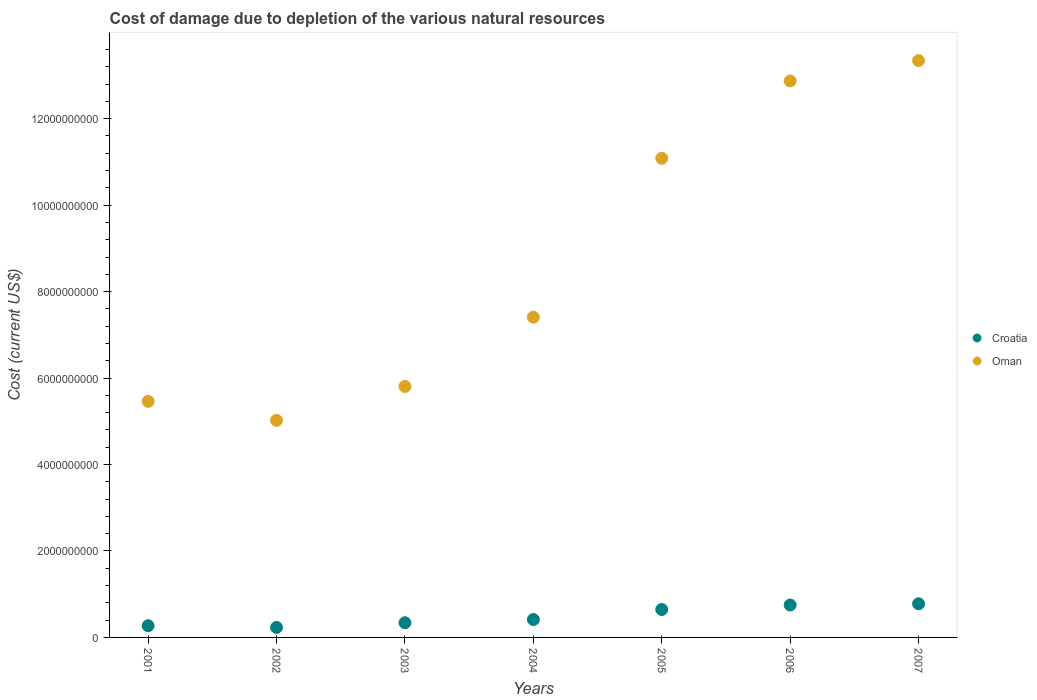Is the number of dotlines equal to the number of legend labels?
Make the answer very short. Yes. What is the cost of damage caused due to the depletion of various natural resources in Croatia in 2002?
Ensure brevity in your answer.  2.31e+08. Across all years, what is the maximum cost of damage caused due to the depletion of various natural resources in Oman?
Provide a short and direct response. 1.33e+1. Across all years, what is the minimum cost of damage caused due to the depletion of various natural resources in Croatia?
Ensure brevity in your answer.  2.31e+08. In which year was the cost of damage caused due to the depletion of various natural resources in Croatia minimum?
Make the answer very short. 2002. What is the total cost of damage caused due to the depletion of various natural resources in Oman in the graph?
Offer a very short reply. 6.10e+1. What is the difference between the cost of damage caused due to the depletion of various natural resources in Oman in 2001 and that in 2002?
Your answer should be very brief. 4.40e+08. What is the difference between the cost of damage caused due to the depletion of various natural resources in Croatia in 2006 and the cost of damage caused due to the depletion of various natural resources in Oman in 2004?
Provide a short and direct response. -6.66e+09. What is the average cost of damage caused due to the depletion of various natural resources in Oman per year?
Give a very brief answer. 8.71e+09. In the year 2005, what is the difference between the cost of damage caused due to the depletion of various natural resources in Oman and cost of damage caused due to the depletion of various natural resources in Croatia?
Keep it short and to the point. 1.04e+1. What is the ratio of the cost of damage caused due to the depletion of various natural resources in Oman in 2001 to that in 2003?
Offer a terse response. 0.94. Is the cost of damage caused due to the depletion of various natural resources in Croatia in 2005 less than that in 2007?
Your response must be concise. Yes. Is the difference between the cost of damage caused due to the depletion of various natural resources in Oman in 2001 and 2002 greater than the difference between the cost of damage caused due to the depletion of various natural resources in Croatia in 2001 and 2002?
Your answer should be compact. Yes. What is the difference between the highest and the second highest cost of damage caused due to the depletion of various natural resources in Oman?
Ensure brevity in your answer.  4.70e+08. What is the difference between the highest and the lowest cost of damage caused due to the depletion of various natural resources in Oman?
Offer a very short reply. 8.32e+09. Does the cost of damage caused due to the depletion of various natural resources in Croatia monotonically increase over the years?
Your response must be concise. No. Is the cost of damage caused due to the depletion of various natural resources in Croatia strictly greater than the cost of damage caused due to the depletion of various natural resources in Oman over the years?
Offer a terse response. No. Does the graph contain any zero values?
Offer a very short reply. No. Where does the legend appear in the graph?
Provide a succinct answer. Center right. What is the title of the graph?
Offer a terse response. Cost of damage due to depletion of the various natural resources. What is the label or title of the X-axis?
Your response must be concise. Years. What is the label or title of the Y-axis?
Keep it short and to the point. Cost (current US$). What is the Cost (current US$) in Croatia in 2001?
Ensure brevity in your answer.  2.71e+08. What is the Cost (current US$) in Oman in 2001?
Your response must be concise. 5.46e+09. What is the Cost (current US$) of Croatia in 2002?
Make the answer very short. 2.31e+08. What is the Cost (current US$) of Oman in 2002?
Your answer should be compact. 5.02e+09. What is the Cost (current US$) of Croatia in 2003?
Offer a terse response. 3.40e+08. What is the Cost (current US$) of Oman in 2003?
Keep it short and to the point. 5.81e+09. What is the Cost (current US$) in Croatia in 2004?
Your answer should be very brief. 4.14e+08. What is the Cost (current US$) in Oman in 2004?
Give a very brief answer. 7.41e+09. What is the Cost (current US$) of Croatia in 2005?
Your answer should be very brief. 6.46e+08. What is the Cost (current US$) in Oman in 2005?
Keep it short and to the point. 1.11e+1. What is the Cost (current US$) of Croatia in 2006?
Offer a terse response. 7.50e+08. What is the Cost (current US$) of Oman in 2006?
Offer a terse response. 1.29e+1. What is the Cost (current US$) of Croatia in 2007?
Your answer should be very brief. 7.78e+08. What is the Cost (current US$) of Oman in 2007?
Give a very brief answer. 1.33e+1. Across all years, what is the maximum Cost (current US$) of Croatia?
Your response must be concise. 7.78e+08. Across all years, what is the maximum Cost (current US$) of Oman?
Offer a very short reply. 1.33e+1. Across all years, what is the minimum Cost (current US$) of Croatia?
Keep it short and to the point. 2.31e+08. Across all years, what is the minimum Cost (current US$) of Oman?
Make the answer very short. 5.02e+09. What is the total Cost (current US$) of Croatia in the graph?
Provide a succinct answer. 3.43e+09. What is the total Cost (current US$) in Oman in the graph?
Ensure brevity in your answer.  6.10e+1. What is the difference between the Cost (current US$) in Croatia in 2001 and that in 2002?
Provide a short and direct response. 3.95e+07. What is the difference between the Cost (current US$) in Oman in 2001 and that in 2002?
Provide a short and direct response. 4.40e+08. What is the difference between the Cost (current US$) in Croatia in 2001 and that in 2003?
Keep it short and to the point. -6.90e+07. What is the difference between the Cost (current US$) in Oman in 2001 and that in 2003?
Provide a succinct answer. -3.44e+08. What is the difference between the Cost (current US$) in Croatia in 2001 and that in 2004?
Your response must be concise. -1.44e+08. What is the difference between the Cost (current US$) in Oman in 2001 and that in 2004?
Make the answer very short. -1.95e+09. What is the difference between the Cost (current US$) in Croatia in 2001 and that in 2005?
Make the answer very short. -3.75e+08. What is the difference between the Cost (current US$) in Oman in 2001 and that in 2005?
Your answer should be compact. -5.62e+09. What is the difference between the Cost (current US$) in Croatia in 2001 and that in 2006?
Make the answer very short. -4.79e+08. What is the difference between the Cost (current US$) of Oman in 2001 and that in 2006?
Provide a succinct answer. -7.41e+09. What is the difference between the Cost (current US$) of Croatia in 2001 and that in 2007?
Make the answer very short. -5.07e+08. What is the difference between the Cost (current US$) of Oman in 2001 and that in 2007?
Make the answer very short. -7.88e+09. What is the difference between the Cost (current US$) in Croatia in 2002 and that in 2003?
Your answer should be compact. -1.08e+08. What is the difference between the Cost (current US$) in Oman in 2002 and that in 2003?
Keep it short and to the point. -7.84e+08. What is the difference between the Cost (current US$) in Croatia in 2002 and that in 2004?
Your answer should be compact. -1.83e+08. What is the difference between the Cost (current US$) of Oman in 2002 and that in 2004?
Your answer should be very brief. -2.39e+09. What is the difference between the Cost (current US$) of Croatia in 2002 and that in 2005?
Offer a terse response. -4.14e+08. What is the difference between the Cost (current US$) of Oman in 2002 and that in 2005?
Provide a succinct answer. -6.06e+09. What is the difference between the Cost (current US$) in Croatia in 2002 and that in 2006?
Your answer should be very brief. -5.18e+08. What is the difference between the Cost (current US$) in Oman in 2002 and that in 2006?
Your answer should be very brief. -7.85e+09. What is the difference between the Cost (current US$) in Croatia in 2002 and that in 2007?
Provide a succinct answer. -5.47e+08. What is the difference between the Cost (current US$) in Oman in 2002 and that in 2007?
Offer a very short reply. -8.32e+09. What is the difference between the Cost (current US$) of Croatia in 2003 and that in 2004?
Make the answer very short. -7.47e+07. What is the difference between the Cost (current US$) of Oman in 2003 and that in 2004?
Give a very brief answer. -1.60e+09. What is the difference between the Cost (current US$) in Croatia in 2003 and that in 2005?
Provide a succinct answer. -3.06e+08. What is the difference between the Cost (current US$) of Oman in 2003 and that in 2005?
Your answer should be very brief. -5.28e+09. What is the difference between the Cost (current US$) in Croatia in 2003 and that in 2006?
Offer a very short reply. -4.10e+08. What is the difference between the Cost (current US$) of Oman in 2003 and that in 2006?
Ensure brevity in your answer.  -7.07e+09. What is the difference between the Cost (current US$) in Croatia in 2003 and that in 2007?
Offer a very short reply. -4.38e+08. What is the difference between the Cost (current US$) in Oman in 2003 and that in 2007?
Give a very brief answer. -7.54e+09. What is the difference between the Cost (current US$) of Croatia in 2004 and that in 2005?
Offer a very short reply. -2.31e+08. What is the difference between the Cost (current US$) of Oman in 2004 and that in 2005?
Ensure brevity in your answer.  -3.68e+09. What is the difference between the Cost (current US$) of Croatia in 2004 and that in 2006?
Keep it short and to the point. -3.35e+08. What is the difference between the Cost (current US$) in Oman in 2004 and that in 2006?
Give a very brief answer. -5.47e+09. What is the difference between the Cost (current US$) of Croatia in 2004 and that in 2007?
Give a very brief answer. -3.64e+08. What is the difference between the Cost (current US$) in Oman in 2004 and that in 2007?
Offer a terse response. -5.94e+09. What is the difference between the Cost (current US$) of Croatia in 2005 and that in 2006?
Offer a terse response. -1.04e+08. What is the difference between the Cost (current US$) of Oman in 2005 and that in 2006?
Keep it short and to the point. -1.79e+09. What is the difference between the Cost (current US$) of Croatia in 2005 and that in 2007?
Give a very brief answer. -1.32e+08. What is the difference between the Cost (current US$) in Oman in 2005 and that in 2007?
Provide a succinct answer. -2.26e+09. What is the difference between the Cost (current US$) of Croatia in 2006 and that in 2007?
Provide a succinct answer. -2.82e+07. What is the difference between the Cost (current US$) in Oman in 2006 and that in 2007?
Give a very brief answer. -4.70e+08. What is the difference between the Cost (current US$) in Croatia in 2001 and the Cost (current US$) in Oman in 2002?
Make the answer very short. -4.75e+09. What is the difference between the Cost (current US$) of Croatia in 2001 and the Cost (current US$) of Oman in 2003?
Provide a short and direct response. -5.53e+09. What is the difference between the Cost (current US$) of Croatia in 2001 and the Cost (current US$) of Oman in 2004?
Your answer should be compact. -7.14e+09. What is the difference between the Cost (current US$) in Croatia in 2001 and the Cost (current US$) in Oman in 2005?
Your response must be concise. -1.08e+1. What is the difference between the Cost (current US$) of Croatia in 2001 and the Cost (current US$) of Oman in 2006?
Provide a short and direct response. -1.26e+1. What is the difference between the Cost (current US$) in Croatia in 2001 and the Cost (current US$) in Oman in 2007?
Offer a terse response. -1.31e+1. What is the difference between the Cost (current US$) in Croatia in 2002 and the Cost (current US$) in Oman in 2003?
Offer a terse response. -5.57e+09. What is the difference between the Cost (current US$) of Croatia in 2002 and the Cost (current US$) of Oman in 2004?
Offer a very short reply. -7.18e+09. What is the difference between the Cost (current US$) in Croatia in 2002 and the Cost (current US$) in Oman in 2005?
Offer a very short reply. -1.09e+1. What is the difference between the Cost (current US$) of Croatia in 2002 and the Cost (current US$) of Oman in 2006?
Make the answer very short. -1.26e+1. What is the difference between the Cost (current US$) in Croatia in 2002 and the Cost (current US$) in Oman in 2007?
Ensure brevity in your answer.  -1.31e+1. What is the difference between the Cost (current US$) in Croatia in 2003 and the Cost (current US$) in Oman in 2004?
Offer a very short reply. -7.07e+09. What is the difference between the Cost (current US$) in Croatia in 2003 and the Cost (current US$) in Oman in 2005?
Provide a short and direct response. -1.07e+1. What is the difference between the Cost (current US$) in Croatia in 2003 and the Cost (current US$) in Oman in 2006?
Ensure brevity in your answer.  -1.25e+1. What is the difference between the Cost (current US$) in Croatia in 2003 and the Cost (current US$) in Oman in 2007?
Provide a succinct answer. -1.30e+1. What is the difference between the Cost (current US$) of Croatia in 2004 and the Cost (current US$) of Oman in 2005?
Offer a very short reply. -1.07e+1. What is the difference between the Cost (current US$) in Croatia in 2004 and the Cost (current US$) in Oman in 2006?
Give a very brief answer. -1.25e+1. What is the difference between the Cost (current US$) in Croatia in 2004 and the Cost (current US$) in Oman in 2007?
Your answer should be compact. -1.29e+1. What is the difference between the Cost (current US$) in Croatia in 2005 and the Cost (current US$) in Oman in 2006?
Offer a terse response. -1.22e+1. What is the difference between the Cost (current US$) of Croatia in 2005 and the Cost (current US$) of Oman in 2007?
Your answer should be compact. -1.27e+1. What is the difference between the Cost (current US$) of Croatia in 2006 and the Cost (current US$) of Oman in 2007?
Offer a very short reply. -1.26e+1. What is the average Cost (current US$) of Croatia per year?
Your response must be concise. 4.90e+08. What is the average Cost (current US$) in Oman per year?
Make the answer very short. 8.71e+09. In the year 2001, what is the difference between the Cost (current US$) of Croatia and Cost (current US$) of Oman?
Your answer should be compact. -5.19e+09. In the year 2002, what is the difference between the Cost (current US$) of Croatia and Cost (current US$) of Oman?
Offer a terse response. -4.79e+09. In the year 2003, what is the difference between the Cost (current US$) in Croatia and Cost (current US$) in Oman?
Ensure brevity in your answer.  -5.47e+09. In the year 2004, what is the difference between the Cost (current US$) in Croatia and Cost (current US$) in Oman?
Keep it short and to the point. -6.99e+09. In the year 2005, what is the difference between the Cost (current US$) of Croatia and Cost (current US$) of Oman?
Your response must be concise. -1.04e+1. In the year 2006, what is the difference between the Cost (current US$) of Croatia and Cost (current US$) of Oman?
Provide a short and direct response. -1.21e+1. In the year 2007, what is the difference between the Cost (current US$) in Croatia and Cost (current US$) in Oman?
Provide a short and direct response. -1.26e+1. What is the ratio of the Cost (current US$) of Croatia in 2001 to that in 2002?
Your answer should be very brief. 1.17. What is the ratio of the Cost (current US$) of Oman in 2001 to that in 2002?
Offer a terse response. 1.09. What is the ratio of the Cost (current US$) of Croatia in 2001 to that in 2003?
Keep it short and to the point. 0.8. What is the ratio of the Cost (current US$) in Oman in 2001 to that in 2003?
Provide a succinct answer. 0.94. What is the ratio of the Cost (current US$) of Croatia in 2001 to that in 2004?
Give a very brief answer. 0.65. What is the ratio of the Cost (current US$) in Oman in 2001 to that in 2004?
Ensure brevity in your answer.  0.74. What is the ratio of the Cost (current US$) of Croatia in 2001 to that in 2005?
Your response must be concise. 0.42. What is the ratio of the Cost (current US$) in Oman in 2001 to that in 2005?
Offer a terse response. 0.49. What is the ratio of the Cost (current US$) of Croatia in 2001 to that in 2006?
Your answer should be very brief. 0.36. What is the ratio of the Cost (current US$) of Oman in 2001 to that in 2006?
Provide a succinct answer. 0.42. What is the ratio of the Cost (current US$) of Croatia in 2001 to that in 2007?
Ensure brevity in your answer.  0.35. What is the ratio of the Cost (current US$) of Oman in 2001 to that in 2007?
Make the answer very short. 0.41. What is the ratio of the Cost (current US$) of Croatia in 2002 to that in 2003?
Make the answer very short. 0.68. What is the ratio of the Cost (current US$) of Oman in 2002 to that in 2003?
Your response must be concise. 0.86. What is the ratio of the Cost (current US$) of Croatia in 2002 to that in 2004?
Offer a terse response. 0.56. What is the ratio of the Cost (current US$) in Oman in 2002 to that in 2004?
Keep it short and to the point. 0.68. What is the ratio of the Cost (current US$) of Croatia in 2002 to that in 2005?
Make the answer very short. 0.36. What is the ratio of the Cost (current US$) of Oman in 2002 to that in 2005?
Keep it short and to the point. 0.45. What is the ratio of the Cost (current US$) of Croatia in 2002 to that in 2006?
Your answer should be very brief. 0.31. What is the ratio of the Cost (current US$) in Oman in 2002 to that in 2006?
Offer a terse response. 0.39. What is the ratio of the Cost (current US$) of Croatia in 2002 to that in 2007?
Your answer should be compact. 0.3. What is the ratio of the Cost (current US$) of Oman in 2002 to that in 2007?
Provide a short and direct response. 0.38. What is the ratio of the Cost (current US$) of Croatia in 2003 to that in 2004?
Your response must be concise. 0.82. What is the ratio of the Cost (current US$) in Oman in 2003 to that in 2004?
Keep it short and to the point. 0.78. What is the ratio of the Cost (current US$) of Croatia in 2003 to that in 2005?
Offer a very short reply. 0.53. What is the ratio of the Cost (current US$) of Oman in 2003 to that in 2005?
Give a very brief answer. 0.52. What is the ratio of the Cost (current US$) in Croatia in 2003 to that in 2006?
Offer a terse response. 0.45. What is the ratio of the Cost (current US$) of Oman in 2003 to that in 2006?
Provide a succinct answer. 0.45. What is the ratio of the Cost (current US$) of Croatia in 2003 to that in 2007?
Your response must be concise. 0.44. What is the ratio of the Cost (current US$) of Oman in 2003 to that in 2007?
Provide a succinct answer. 0.44. What is the ratio of the Cost (current US$) of Croatia in 2004 to that in 2005?
Your answer should be very brief. 0.64. What is the ratio of the Cost (current US$) in Oman in 2004 to that in 2005?
Provide a short and direct response. 0.67. What is the ratio of the Cost (current US$) in Croatia in 2004 to that in 2006?
Keep it short and to the point. 0.55. What is the ratio of the Cost (current US$) in Oman in 2004 to that in 2006?
Make the answer very short. 0.58. What is the ratio of the Cost (current US$) of Croatia in 2004 to that in 2007?
Provide a succinct answer. 0.53. What is the ratio of the Cost (current US$) of Oman in 2004 to that in 2007?
Your answer should be very brief. 0.56. What is the ratio of the Cost (current US$) of Croatia in 2005 to that in 2006?
Give a very brief answer. 0.86. What is the ratio of the Cost (current US$) in Oman in 2005 to that in 2006?
Offer a terse response. 0.86. What is the ratio of the Cost (current US$) of Croatia in 2005 to that in 2007?
Offer a terse response. 0.83. What is the ratio of the Cost (current US$) in Oman in 2005 to that in 2007?
Keep it short and to the point. 0.83. What is the ratio of the Cost (current US$) of Croatia in 2006 to that in 2007?
Provide a succinct answer. 0.96. What is the ratio of the Cost (current US$) in Oman in 2006 to that in 2007?
Give a very brief answer. 0.96. What is the difference between the highest and the second highest Cost (current US$) of Croatia?
Ensure brevity in your answer.  2.82e+07. What is the difference between the highest and the second highest Cost (current US$) of Oman?
Provide a short and direct response. 4.70e+08. What is the difference between the highest and the lowest Cost (current US$) in Croatia?
Offer a very short reply. 5.47e+08. What is the difference between the highest and the lowest Cost (current US$) of Oman?
Your answer should be compact. 8.32e+09. 